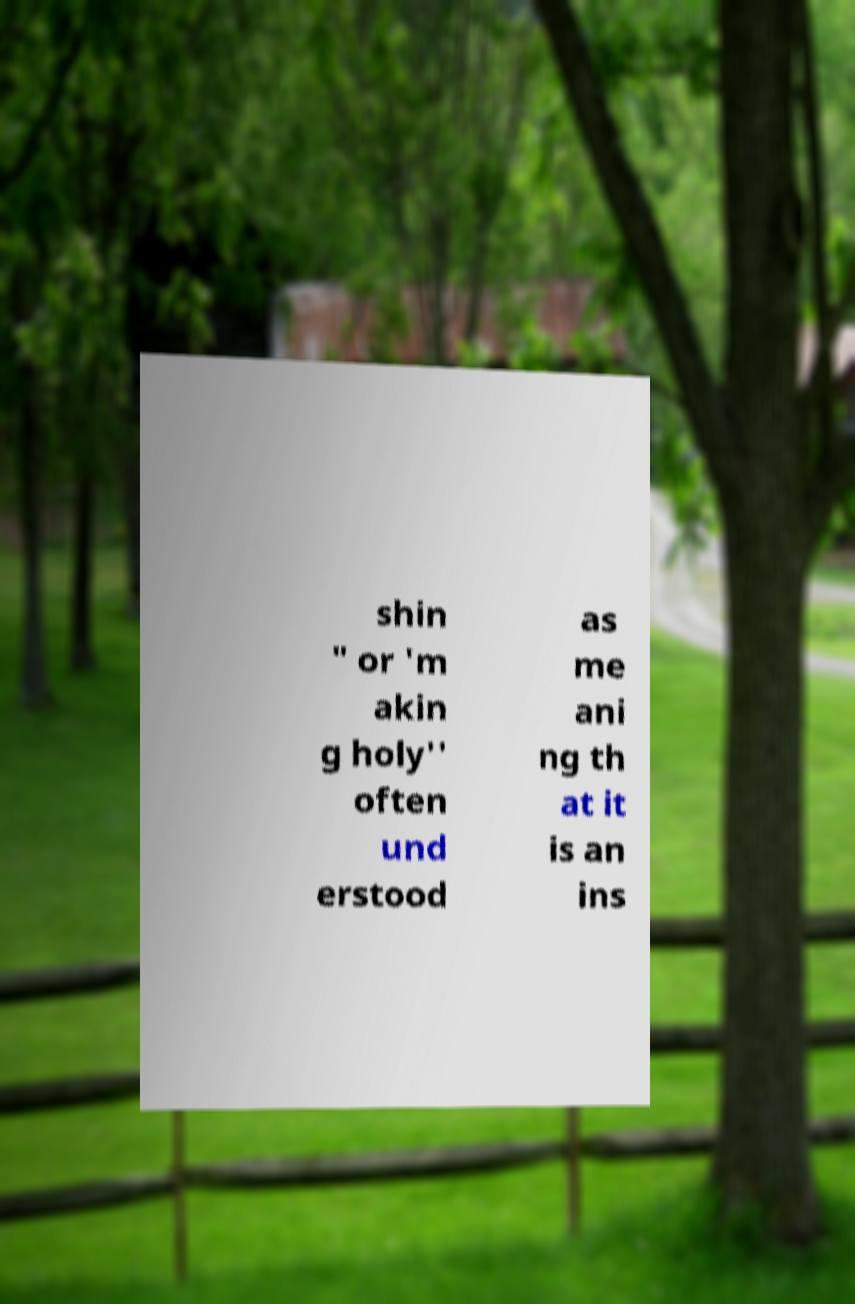There's text embedded in this image that I need extracted. Can you transcribe it verbatim? shin " or 'm akin g holy'' often und erstood as me ani ng th at it is an ins 